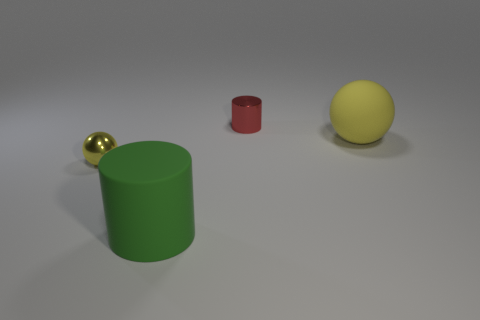There is a thing that is both right of the yellow shiny sphere and in front of the large matte sphere; what is its size?
Ensure brevity in your answer.  Large. Is the red object made of the same material as the small thing that is left of the large green cylinder?
Ensure brevity in your answer.  Yes. Are there fewer yellow rubber spheres that are to the right of the large ball than tiny yellow metallic things in front of the tiny yellow ball?
Give a very brief answer. No. There is a tiny thing to the right of the tiny yellow object; what is its material?
Offer a very short reply. Metal. There is a thing that is behind the shiny sphere and in front of the red shiny cylinder; what is its color?
Offer a terse response. Yellow. How many other objects are the same color as the large rubber cylinder?
Your answer should be very brief. 0. The tiny metal object on the left side of the shiny cylinder is what color?
Give a very brief answer. Yellow. Is there a sphere that has the same size as the metal cylinder?
Your response must be concise. Yes. There is a yellow object that is the same size as the red object; what material is it?
Your answer should be compact. Metal. How many objects are either large matte objects that are to the right of the metallic cylinder or big matte objects that are behind the small yellow shiny sphere?
Provide a succinct answer. 1. 